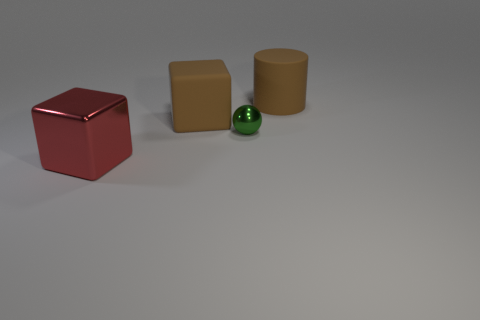Add 3 purple blocks. How many objects exist? 7 Subtract all balls. How many objects are left? 3 Subtract all rubber cylinders. Subtract all big cylinders. How many objects are left? 2 Add 1 big red cubes. How many big red cubes are left? 2 Add 2 tiny gray rubber cylinders. How many tiny gray rubber cylinders exist? 2 Subtract 0 blue spheres. How many objects are left? 4 